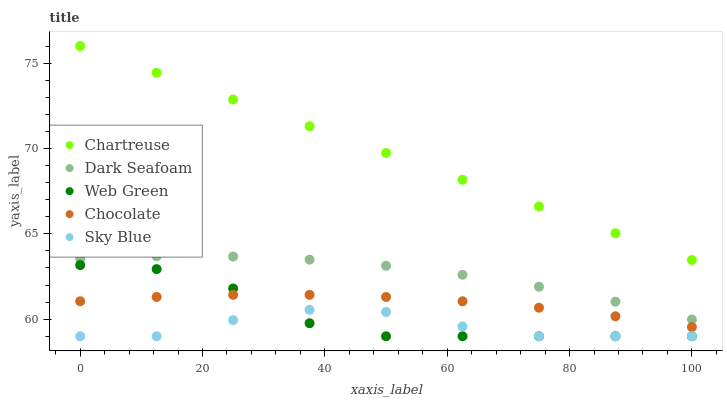Does Sky Blue have the minimum area under the curve?
Answer yes or no. Yes. Does Chartreuse have the maximum area under the curve?
Answer yes or no. Yes. Does Dark Seafoam have the minimum area under the curve?
Answer yes or no. No. Does Dark Seafoam have the maximum area under the curve?
Answer yes or no. No. Is Chartreuse the smoothest?
Answer yes or no. Yes. Is Web Green the roughest?
Answer yes or no. Yes. Is Dark Seafoam the smoothest?
Answer yes or no. No. Is Dark Seafoam the roughest?
Answer yes or no. No. Does Sky Blue have the lowest value?
Answer yes or no. Yes. Does Dark Seafoam have the lowest value?
Answer yes or no. No. Does Chartreuse have the highest value?
Answer yes or no. Yes. Does Dark Seafoam have the highest value?
Answer yes or no. No. Is Chocolate less than Dark Seafoam?
Answer yes or no. Yes. Is Chartreuse greater than Chocolate?
Answer yes or no. Yes. Does Sky Blue intersect Web Green?
Answer yes or no. Yes. Is Sky Blue less than Web Green?
Answer yes or no. No. Is Sky Blue greater than Web Green?
Answer yes or no. No. Does Chocolate intersect Dark Seafoam?
Answer yes or no. No. 